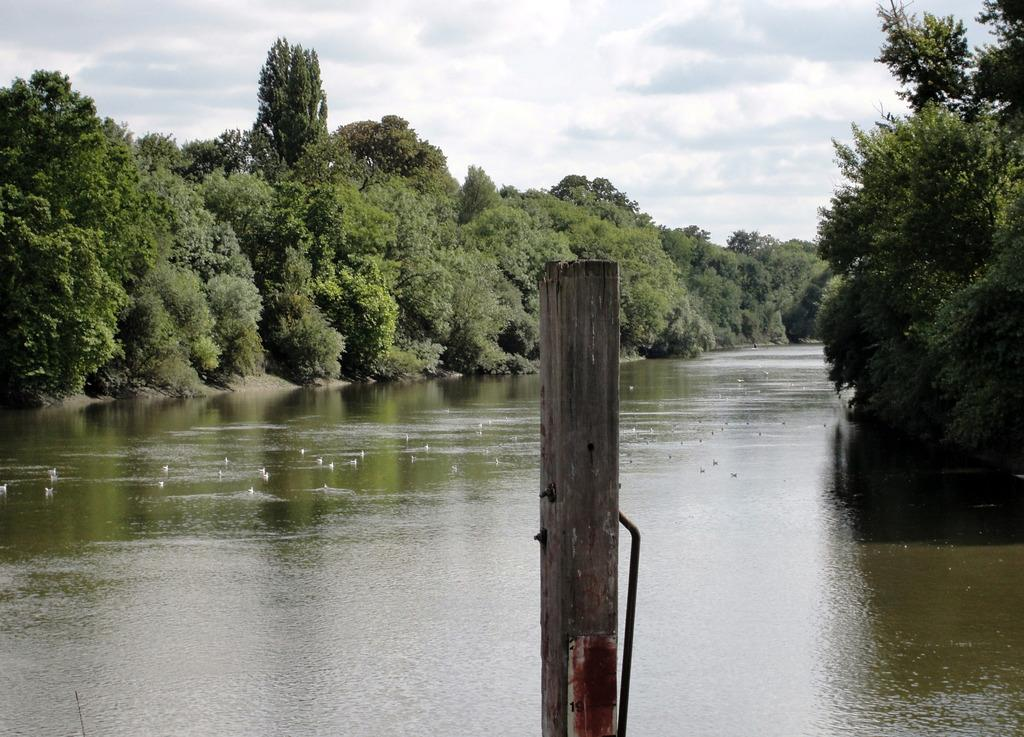What object made of wood can be seen in the image? There is a wooden stick in the image. What is the primary element in the image? There is water with some objects in the image. What type of natural environment is visible in the background of the image? Trees and the sky are visible in the background of the image. How many songs can be heard playing in the background of the image? There are no songs or sounds present in the image, so it is not possible to determine how many songs might be heard. 